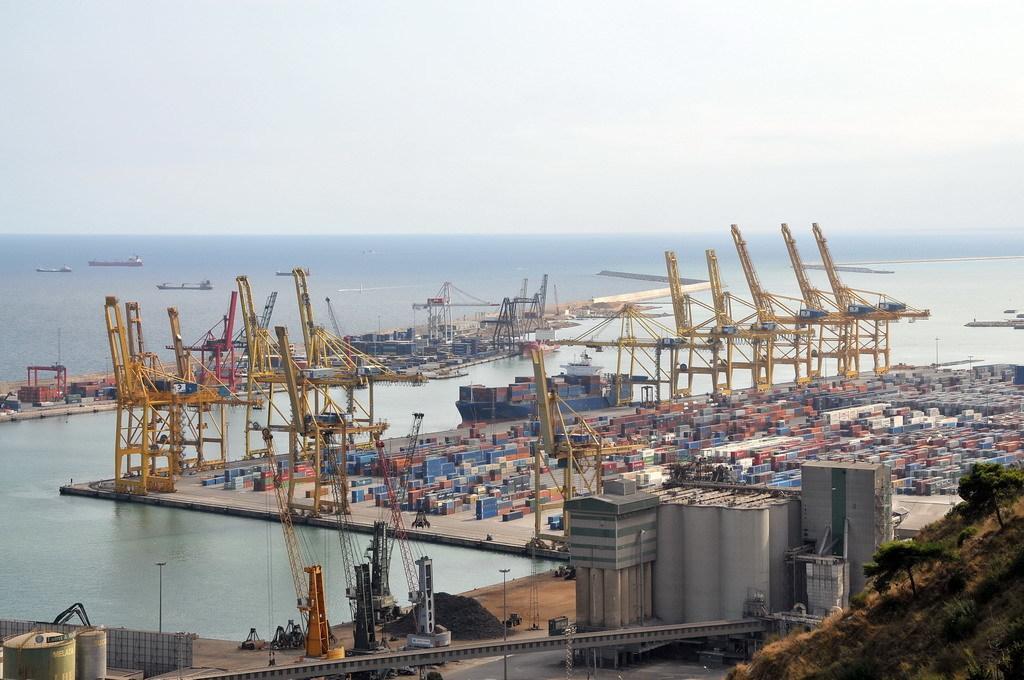In one or two sentences, can you explain what this image depicts? This picture is clicked outside the city. In the foreground we can see the metal stands, bridge and trees and some buildings. In the center there is a water body and we can see many number of items and metal stands. In the background there is a sky and some items in the water body. 